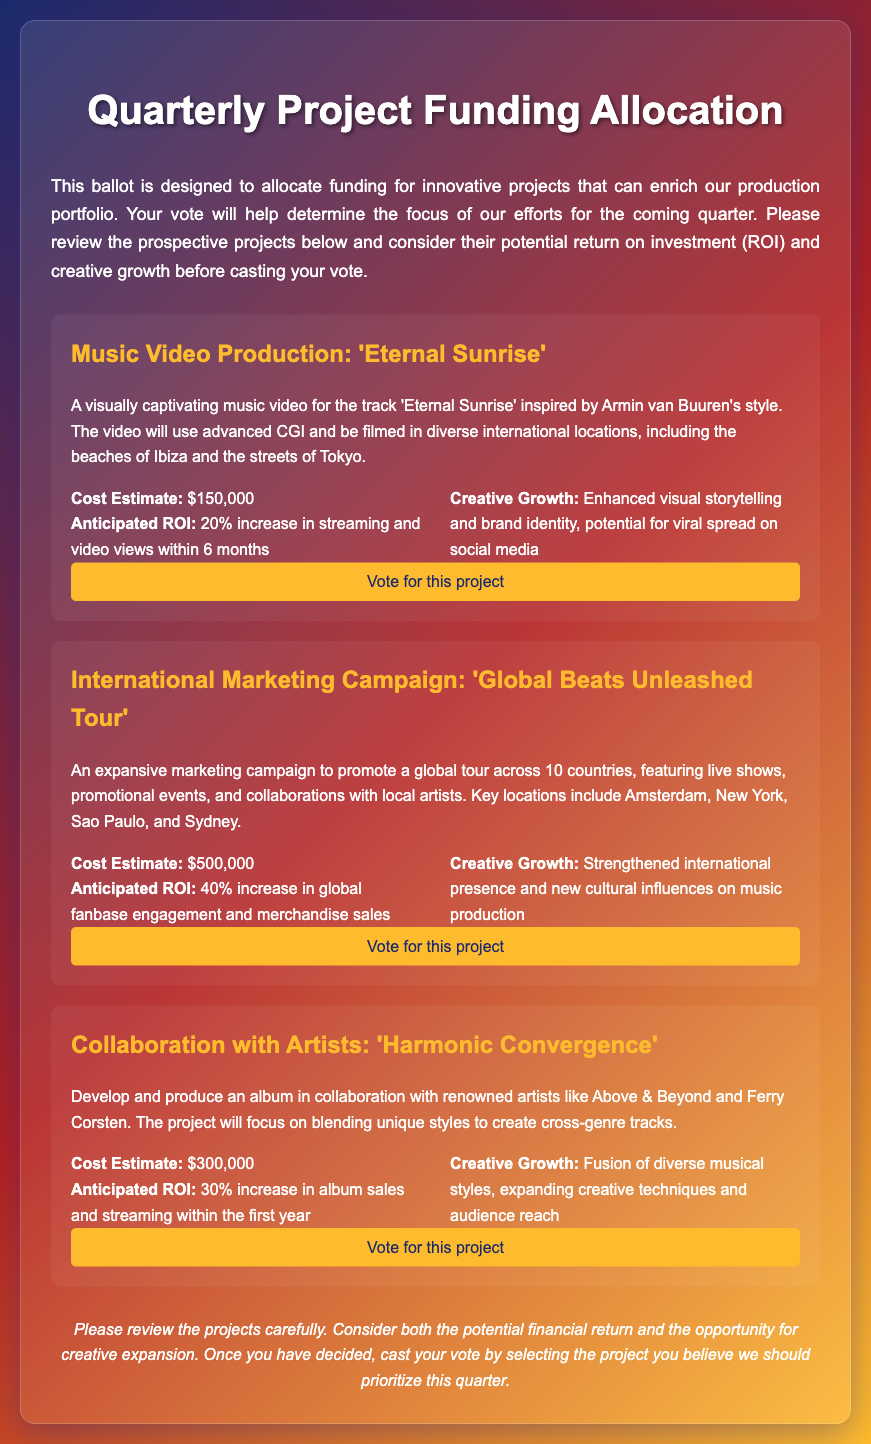What is the title of the music video project? The title of the music video project is 'Eternal Sunrise'.
Answer: 'Eternal Sunrise' What is the cost estimate for the International Marketing Campaign? The cost estimate for the International Marketing Campaign is stated in the document.
Answer: $500,000 What is the anticipated ROI for the collaboration with artists project? The anticipated ROI for the collaboration with artists project is mentioned in the details.
Answer: 30% Which key locations are included in the international marketing campaign? The document lists key locations in the international marketing campaign.
Answer: Amsterdam, New York, Sao Paulo, Sydney What creative growth does the music video production aim to achieve? The document specifies the creative growth goals for the music video production project.
Answer: Enhanced visual storytelling and brand identity How many countries are involved in the Global Beats Unleashed Tour? The number of countries involved in the tour is provided in the project description.
Answer: 10 What type of artists will be collaborated with in the 'Harmonic Convergence' project? The document describes the type of artists involved in the project.
Answer: Renowned artists What is the anticipated increase in streaming and video views for the music video? The anticipated increase is detailed in the project overview.
Answer: 20% increase What is the main focus of the 'Harmonic Convergence' collaboration? The main focus is articulated in the project description.
Answer: Blending unique styles to create cross-genre tracks 